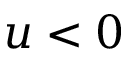Convert formula to latex. <formula><loc_0><loc_0><loc_500><loc_500>u < 0</formula> 